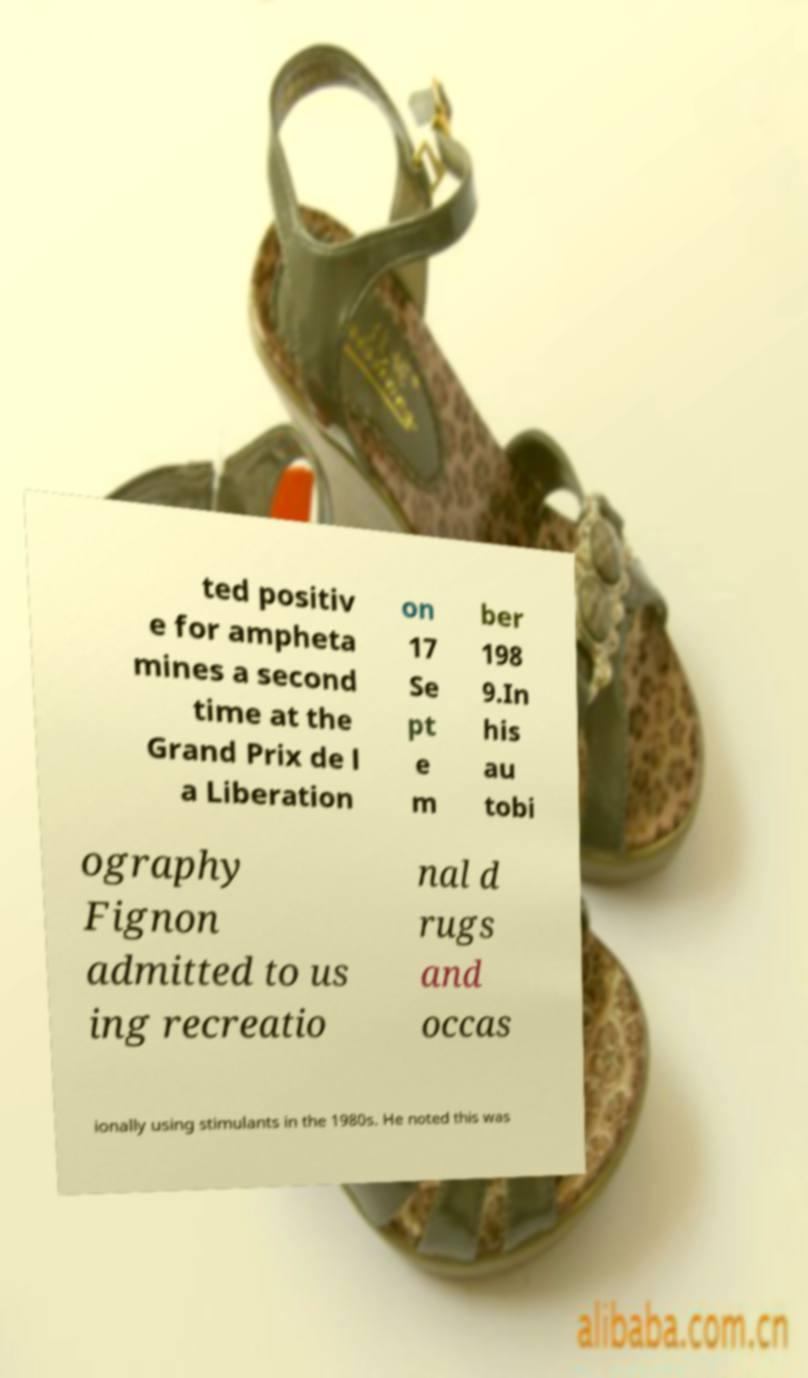There's text embedded in this image that I need extracted. Can you transcribe it verbatim? ted positiv e for ampheta mines a second time at the Grand Prix de l a Liberation on 17 Se pt e m ber 198 9.In his au tobi ography Fignon admitted to us ing recreatio nal d rugs and occas ionally using stimulants in the 1980s. He noted this was 